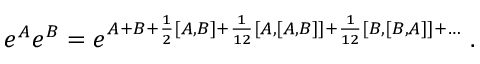<formula> <loc_0><loc_0><loc_500><loc_500>e ^ { A } e ^ { B } = e ^ { A + B + { \frac { 1 } { 2 } } [ A , B ] + { \frac { 1 } { 1 2 } } [ A , [ A , B ] ] + { \frac { 1 } { 1 2 } } [ B , [ B , A ] ] + \dots } \ .</formula> 